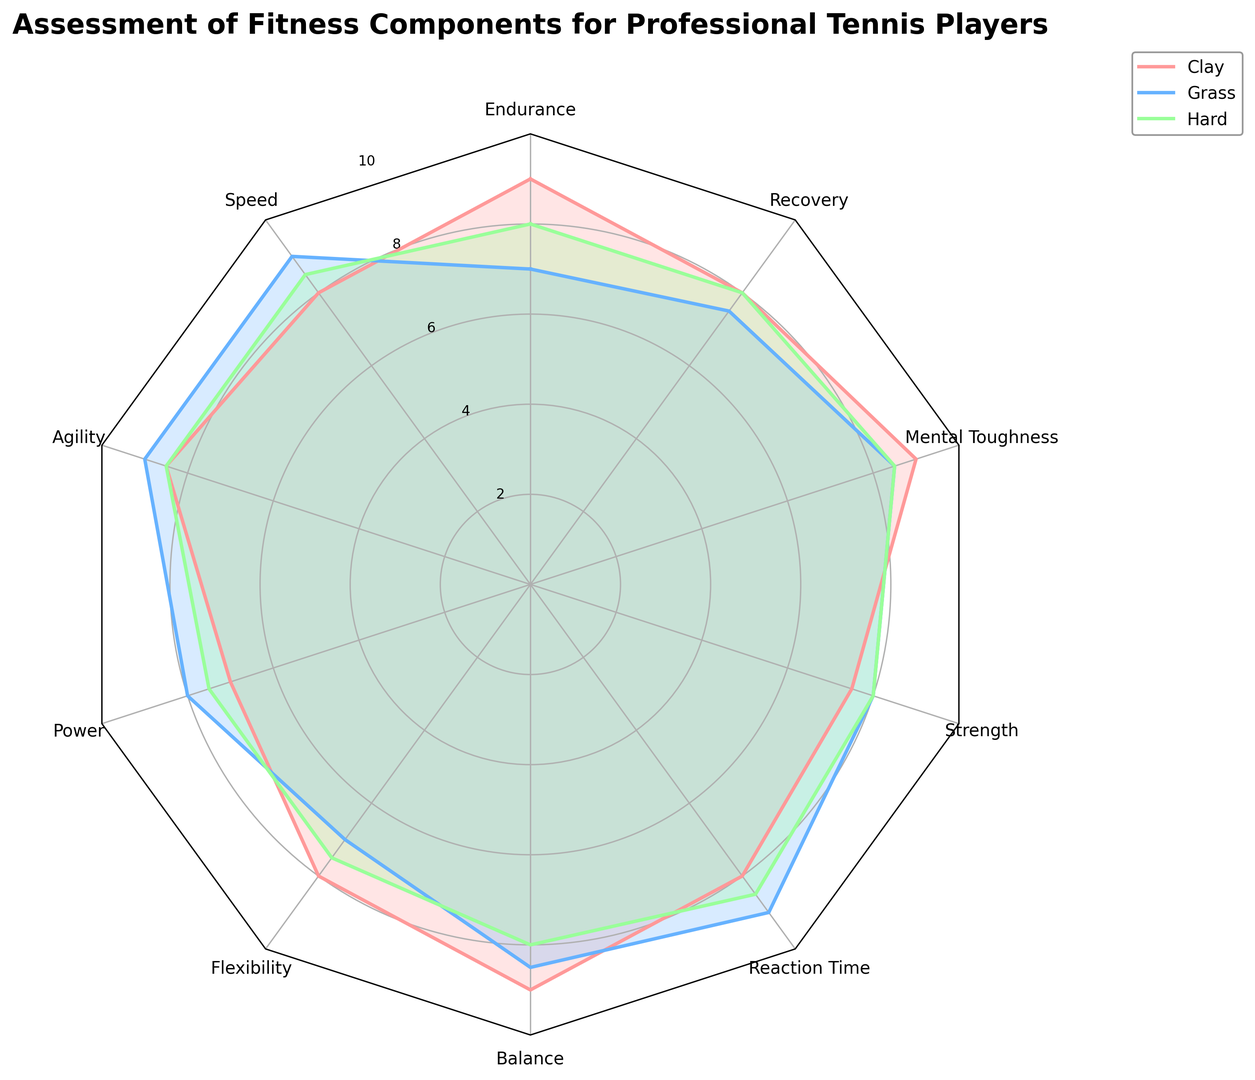How does the balance of players on clay courts compare to those on hard courts? Look for the 'Balance' category on the radar chart and compare the values for clay and hard courts. For clay, the value is 9, and for hard, the value is 8.
Answer: Balance is higher on clay courts Which surface demonstrates the highest power value? Find the 'Power' category and identify the surface with the highest value. The values are 7 for clay, 8 for grass, and 7.5 for hard. Grass has the highest value of 8.
Answer: Grass What is the average speed score across all surfaces? Look at the 'Speed' category for each surface. The values are 8 for clay, 9 for grass, and 8.5 for hard. The average is (8 + 9 + 8.5)/3 = 25.5/3 = 8.5.
Answer: 8.5 Which fitness component has the smallest range of scores across the three surfaces? Calculate the range for each category: Endurance (9-7=2), Speed (9-8=1), Agility (9-8.5=0.5), Power (8-7=1), Flexibility (8-7=1), Balance (9-8=1), Reaction Time (9-8=1), Strength (8-7.5=0.5), Mental Toughness (9-8.5=0.5), Recovery (8-7.5=0.5). The smallest range is for Agility, Strength, Mental Toughness, and Recovery.
Answer: Agility, Strength, Mental Toughness, Recovery Compare the mental toughness of players on grass and hard courts. Look for the 'Mental Toughness' category and compare the values for grass and hard courts. For grass, the value is 8.5, and for hard, the value is also 8.5.
Answer: Equal Which surface has the lowest flexibility score? Look at the 'Flexibility' category and identify the surface with the lowest value. The values are 8 for clay, 7 for grass, and 7.5 for hard. Grass has the lowest value of 7.
Answer: Grass How does the reaction time on grass compare to clay courts? Look for the 'Reaction Time' category and compare the values for grass and clay courts. For grass, the value is 9, and for clay, the value is 8.
Answer: Grass is higher What is the combined score for strength on clay and hard courts? Look for the 'Strength' category values for clay and hard courts. For clay, the value is 7.5, and for hard, it is 8. Combined score is 7.5 + 8 = 15.5.
Answer: 15.5 Which component has the highest score on clay courts? Look through all categories for clay courts to find the highest value, which is 9 for Endurance, Balance, and Mental Toughness.
Answer: Endurance, Balance, Mental Toughness 